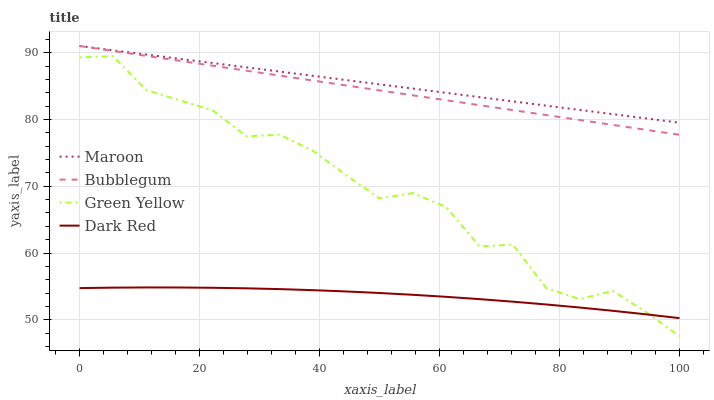Does Dark Red have the minimum area under the curve?
Answer yes or no. Yes. Does Maroon have the maximum area under the curve?
Answer yes or no. Yes. Does Green Yellow have the minimum area under the curve?
Answer yes or no. No. Does Green Yellow have the maximum area under the curve?
Answer yes or no. No. Is Bubblegum the smoothest?
Answer yes or no. Yes. Is Green Yellow the roughest?
Answer yes or no. Yes. Is Green Yellow the smoothest?
Answer yes or no. No. Is Bubblegum the roughest?
Answer yes or no. No. Does Bubblegum have the lowest value?
Answer yes or no. No. Does Maroon have the highest value?
Answer yes or no. Yes. Does Green Yellow have the highest value?
Answer yes or no. No. Is Dark Red less than Maroon?
Answer yes or no. Yes. Is Maroon greater than Green Yellow?
Answer yes or no. Yes. Does Dark Red intersect Maroon?
Answer yes or no. No. 